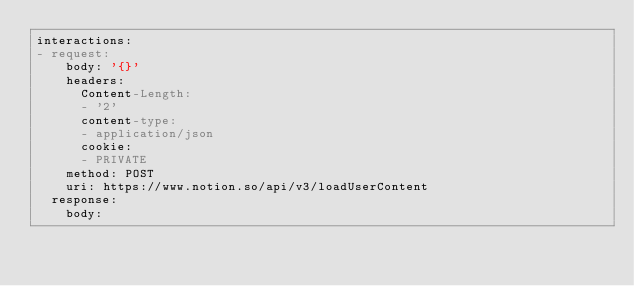Convert code to text. <code><loc_0><loc_0><loc_500><loc_500><_YAML_>interactions:
- request:
    body: '{}'
    headers:
      Content-Length:
      - '2'
      content-type:
      - application/json
      cookie:
      - PRIVATE
    method: POST
    uri: https://www.notion.so/api/v3/loadUserContent
  response:
    body:</code> 